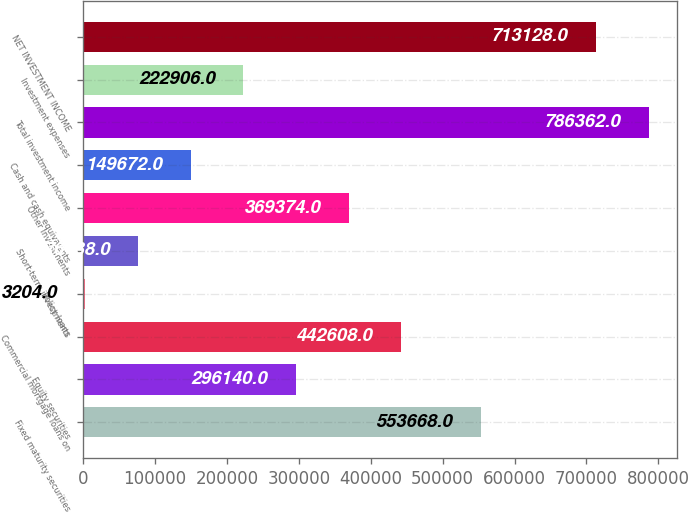Convert chart to OTSL. <chart><loc_0><loc_0><loc_500><loc_500><bar_chart><fcel>Fixed maturity securities<fcel>Equity securities<fcel>Commercial mortgage loans on<fcel>Policy loans<fcel>Short-term investments<fcel>Other investments<fcel>Cash and cash equivalents<fcel>Total investment income<fcel>Investment expenses<fcel>NET INVESTMENT INCOME<nl><fcel>553668<fcel>296140<fcel>442608<fcel>3204<fcel>76438<fcel>369374<fcel>149672<fcel>786362<fcel>222906<fcel>713128<nl></chart> 